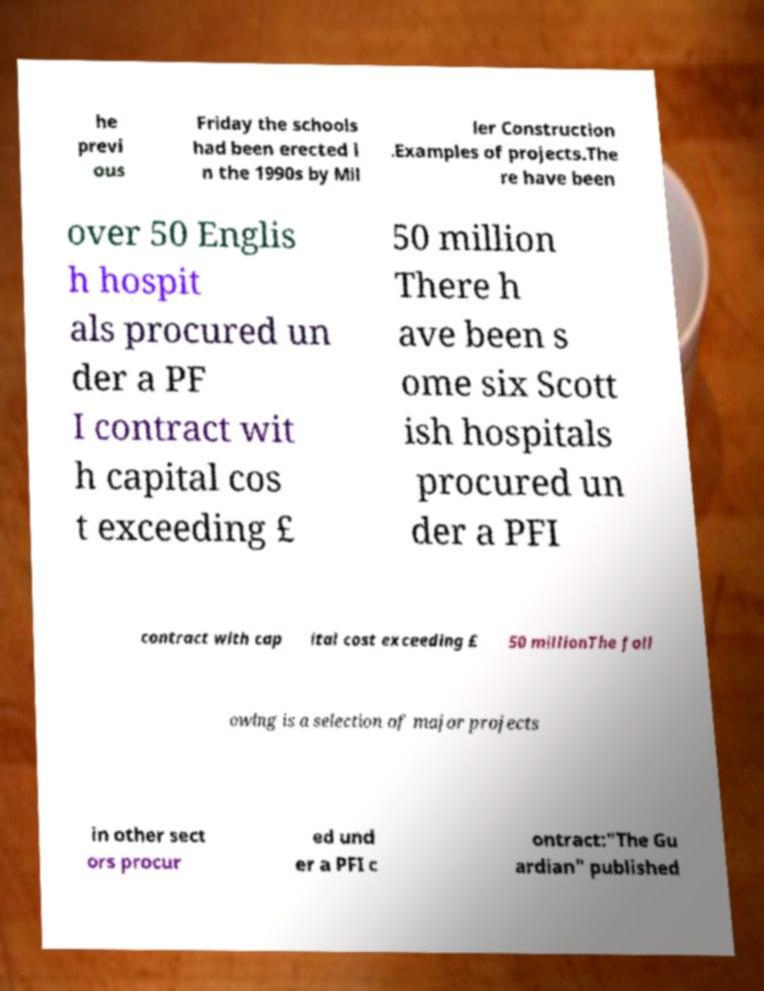I need the written content from this picture converted into text. Can you do that? he previ ous Friday the schools had been erected i n the 1990s by Mil ler Construction .Examples of projects.The re have been over 50 Englis h hospit als procured un der a PF I contract wit h capital cos t exceeding £ 50 million There h ave been s ome six Scott ish hospitals procured un der a PFI contract with cap ital cost exceeding £ 50 millionThe foll owing is a selection of major projects in other sect ors procur ed und er a PFI c ontract:"The Gu ardian" published 